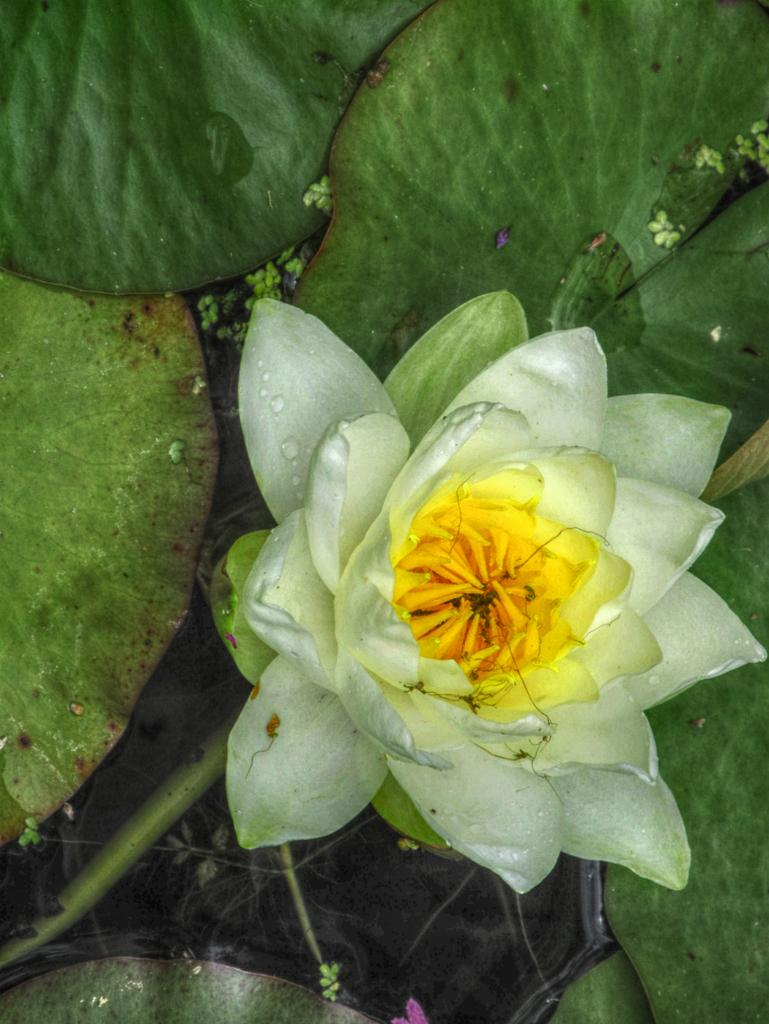What type of plant can be seen in the image? There is a flower in the image. What else is present on the plant besides the flower? There are leaves in the image. What color are the teeth of the person in the image? There is no person present in the image, so we cannot determine the color of their teeth. 